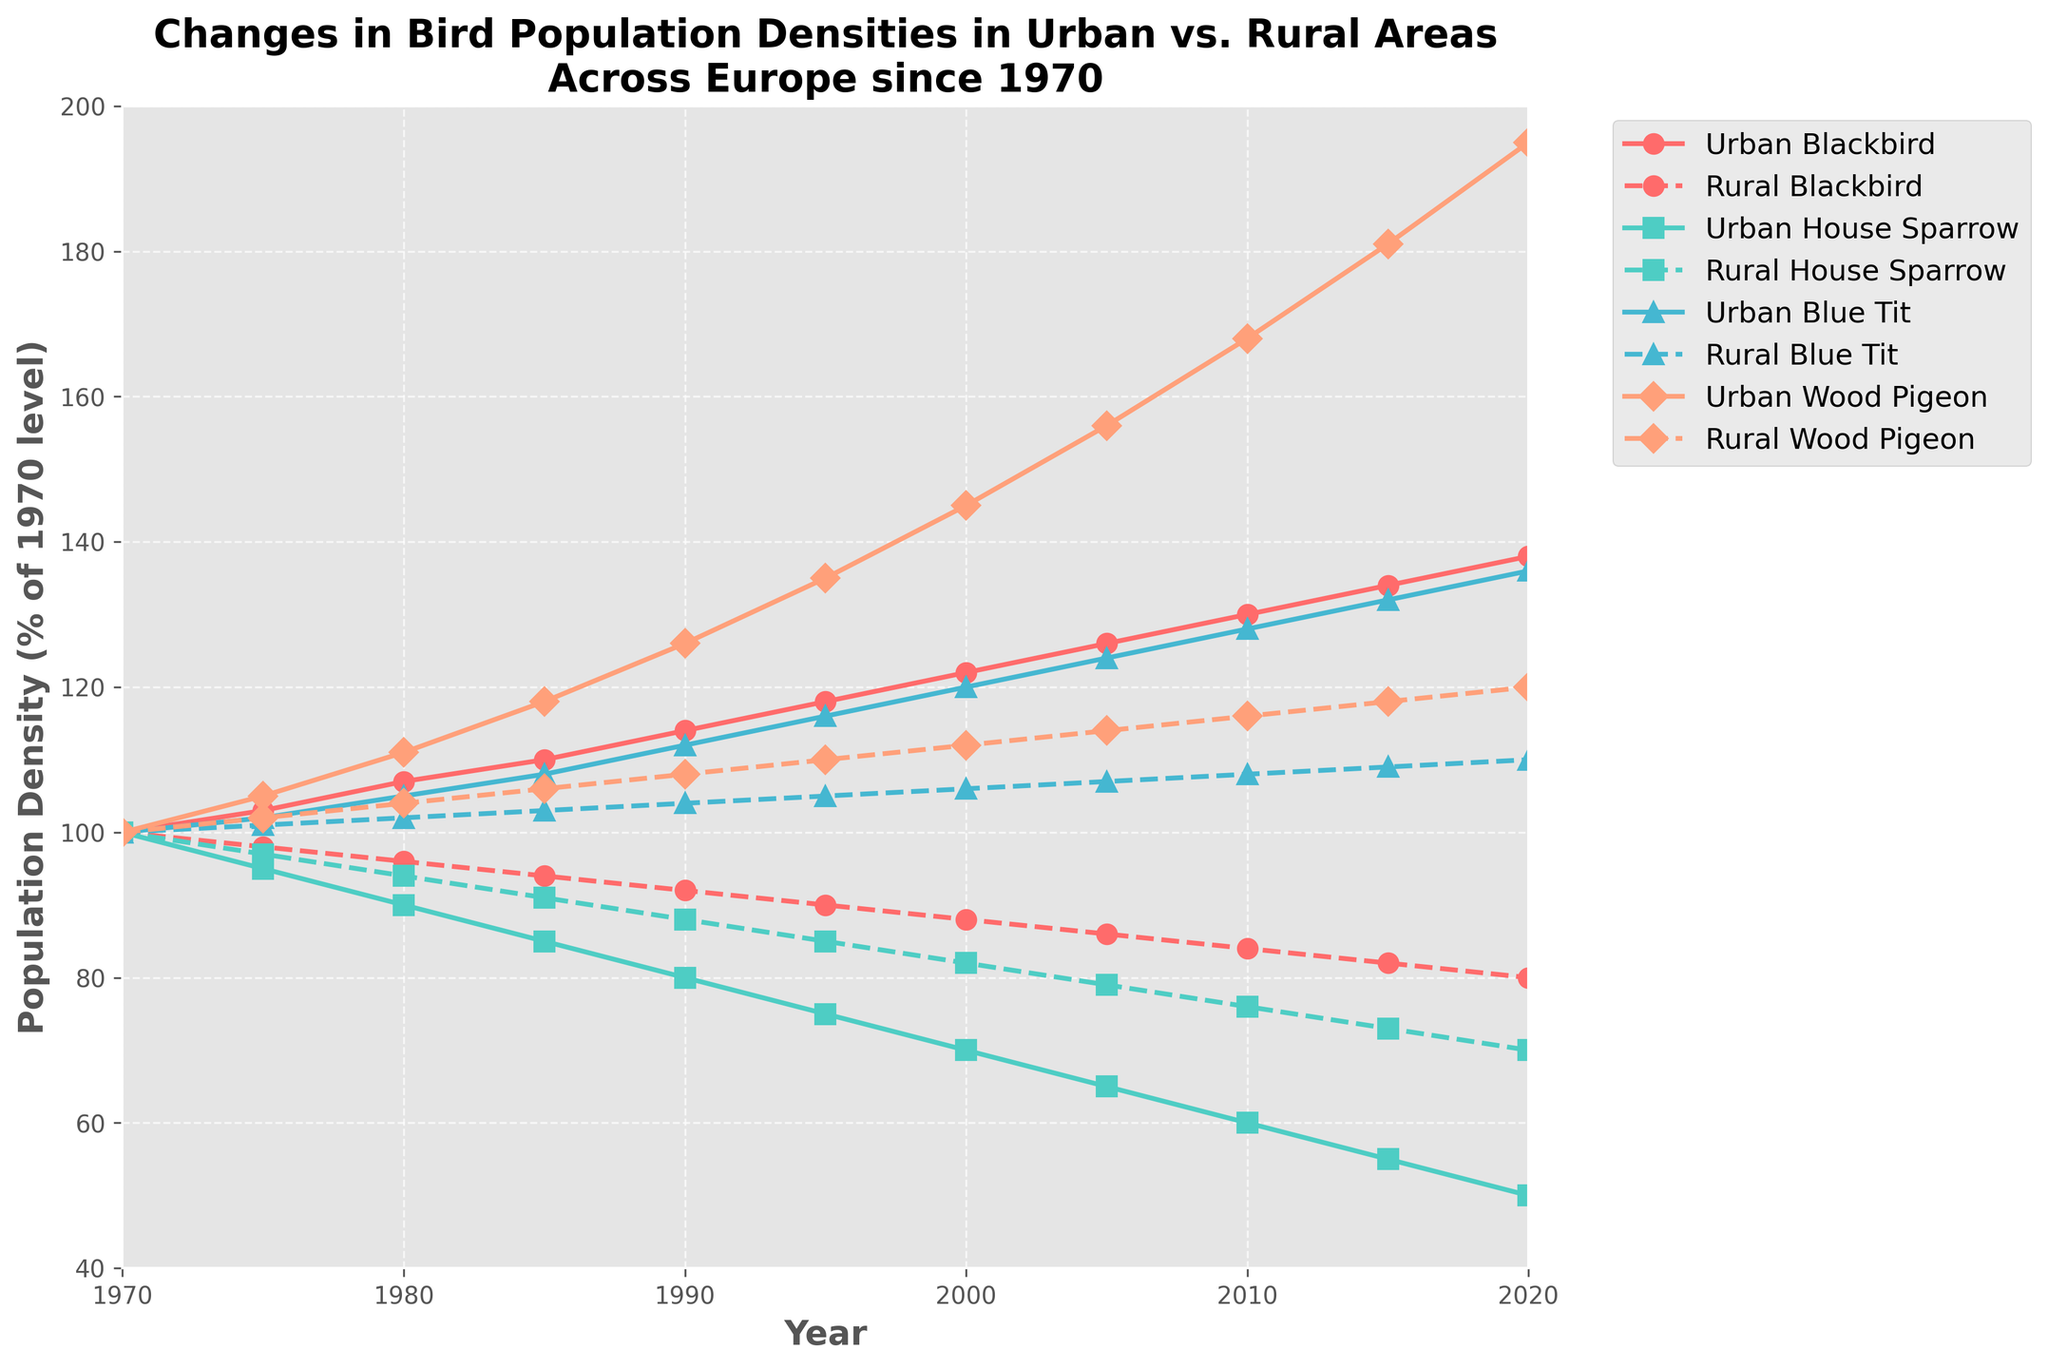Which species shows the most significant increase in population density in urban areas from 1970 to 2020? To find the most significant increase, look at the end point (2020) and compare it to the start point (1970) for each species in urban areas. Calculate the difference for each species: Blackbird (138-100 = 38), House Sparrow (50-100 = -50), Blue Tit (136-100 = 36), Wood Pigeon (195-100 = 95). The Wood Pigeon shows the highest increase (95).
Answer: Wood Pigeon Which species in rural areas has the least decline in population density from 1970 to 2020? To find the least decline, compare the 1970 value to the 2020 value for each species in rural areas: Blackbird (100-80 = 20), House Sparrow (100-70 = 30), Blue Tit (100-110 = +10), Wood Pigeon (100-120 = +20). The Blue Tit actually increases (by 10), meaning it has the least decline (in fact an increase).
Answer: Blue Tit Are the population densities of urban Wood Pigeons and rural Wood Pigeons closer or further apart in 2020 compared to 1970? Compare the differences between urban and rural Wood Pigeons for both years. In 1970: 100 (urban) - 100 (rural) = 0. In 2020: 195 (urban) - 120 (rural) = 75. They are further apart in 2020.
Answer: Further apart Which species has a higher urban population density than its rural counterpart throughout the entire period from 1970 to 2020? Look for a species whose urban line is consistently above its rural line. Urban Blackbird is consistently above Rural Blackbird in every year.
Answer: Blackbird For which species is the population trend in urban areas the opposite to that in rural areas over the entire period? Compare each species' trends in urban and rural areas. Blue Tit shows this pattern: increasing in urban areas (100 to 136) and increasing in rural areas (100 to 110). Same goes for Wood Pigeon. Both trends align rather than oppose. All species have roughly similar trends between urban and rural. No species shows opposite trends for the entire period.
Answer: None In which year was the difference between the urban and rural population densities of House Sparrows the greatest? For each year, calculate the absolute difference between urban and rural House Sparrow densities. Differences (Urban - Rural): 1970 (100-100=0), 1975 (95-97=2), 1980 (90-94=4), 1985 (85-91=6), 1990 (80-88=8), 1995 (75-85=10), 2000 (70-82=12), 2005 (65-79=14), 2010 (60-76=16), 2015 (55-73=18), 2020 (50-70=20). The difference is greatest in 2020 (20).
Answer: 2020 Which species had the smallest population density in both urban and rural areas in 2010? Check the population densities for each species in both locations for 2010. Urban House Sparrow had the smallest urban population density at 60 and Rural House Sparrow had the smallest rural population at 76. House Sparrow had the smallest density in both settings.
Answer: House Sparrow 